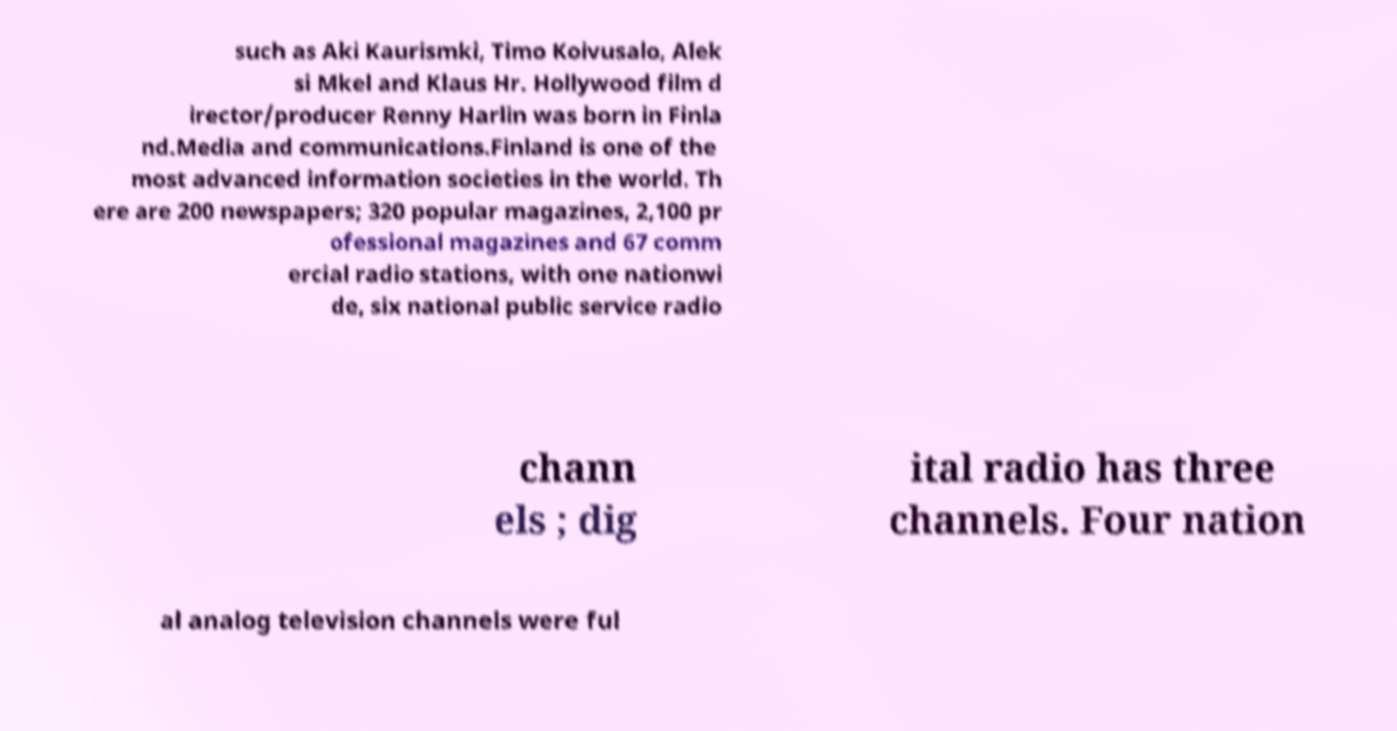What messages or text are displayed in this image? I need them in a readable, typed format. such as Aki Kaurismki, Timo Koivusalo, Alek si Mkel and Klaus Hr. Hollywood film d irector/producer Renny Harlin was born in Finla nd.Media and communications.Finland is one of the most advanced information societies in the world. Th ere are 200 newspapers; 320 popular magazines, 2,100 pr ofessional magazines and 67 comm ercial radio stations, with one nationwi de, six national public service radio chann els ; dig ital radio has three channels. Four nation al analog television channels were ful 